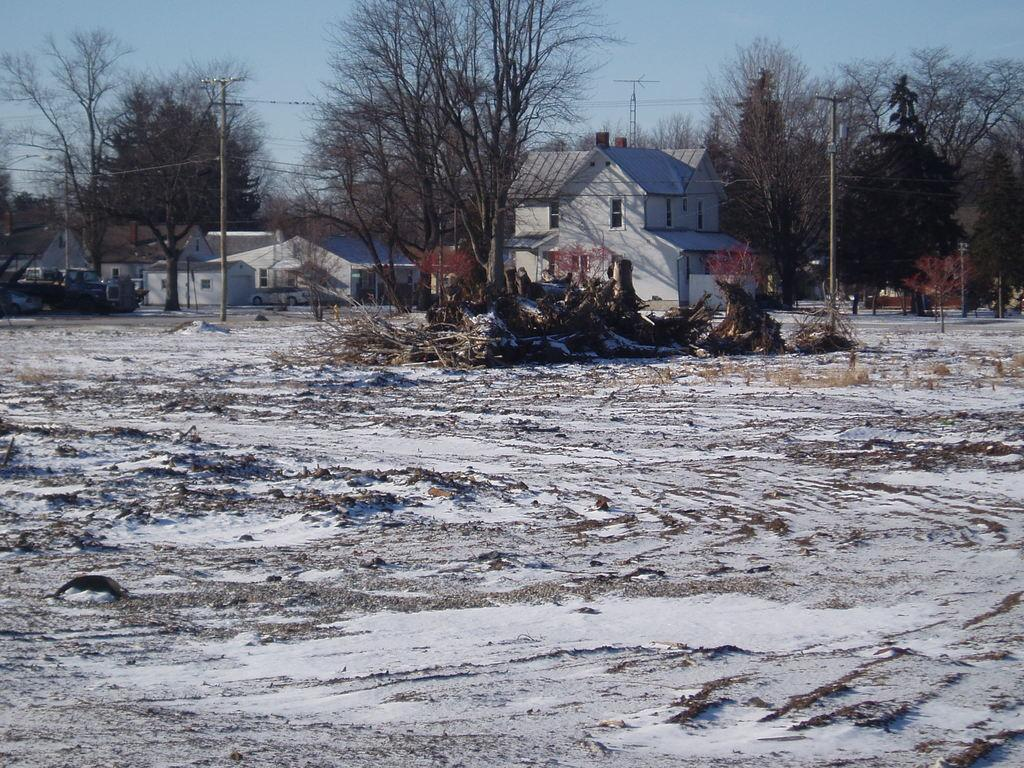What type of natural elements can be seen in the image? There are trees and plants visible in the image. What type of man-made structures are present in the image? There are houses and poles visible in the image. What is the mode of transportation in the image? There is a vehicle in the image. What is the ground covered with in the image? There is snow on the ground in the image. What is visible in the background of the image? The sky is visible in the background of the image. Can you tell me what time of day it is in the image based on the behavior of the monkey? There is no monkey present in the image, so it is not possible to determine the time of day based on its behavior. What type of beast is seen roaming around the group of twigs in the image? There is no beast present in the image, and the group of twigs is not associated with any living creature. 